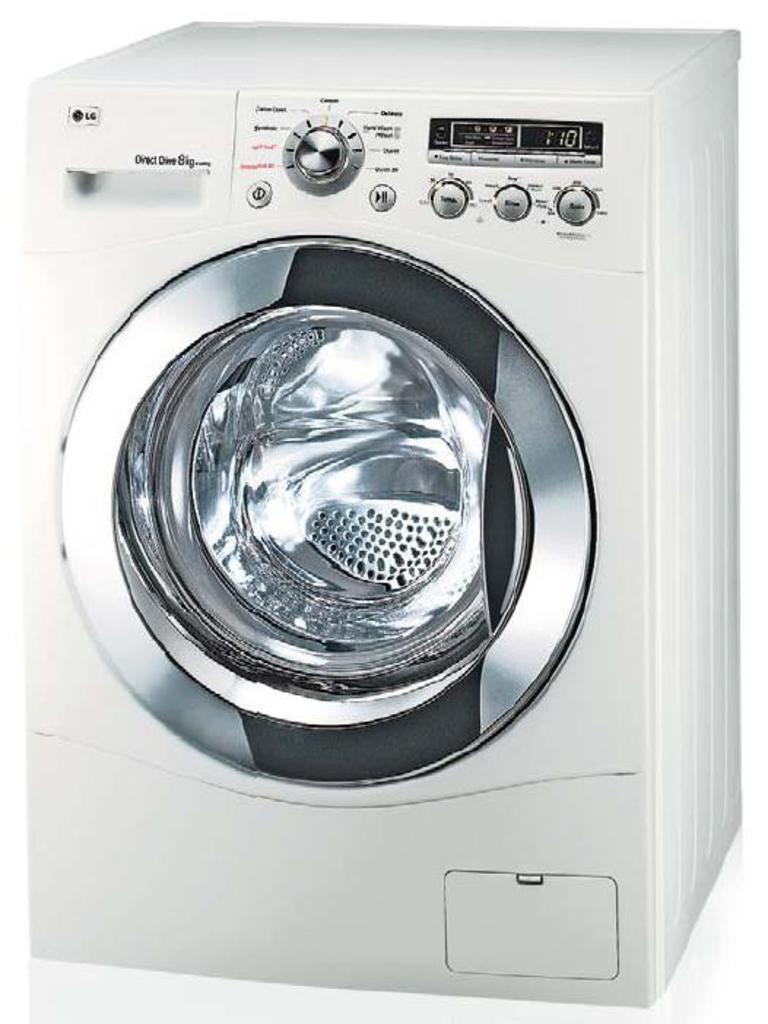Can you describe this image briefly? In this image we can see there is a washing machine. 